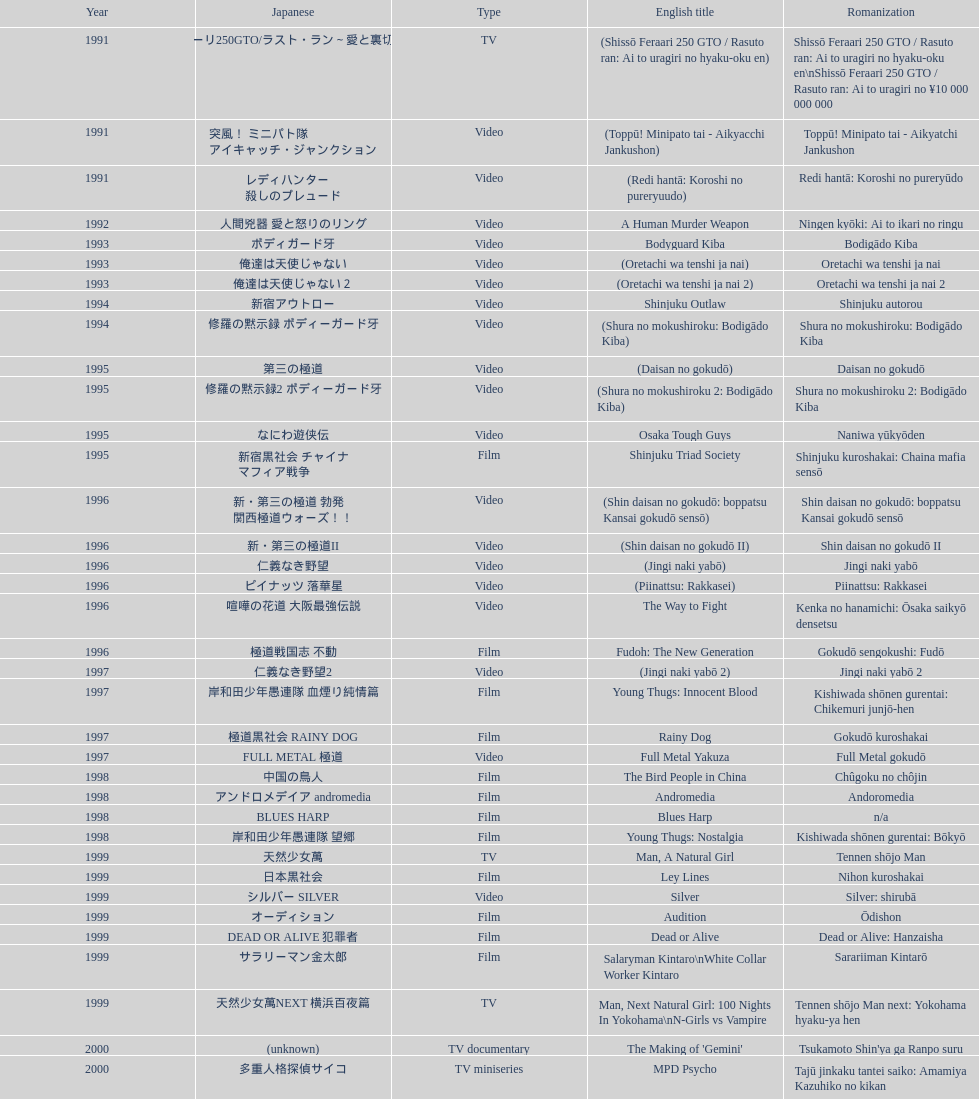Name a film that was released before 1996. Shinjuku Triad Society. 